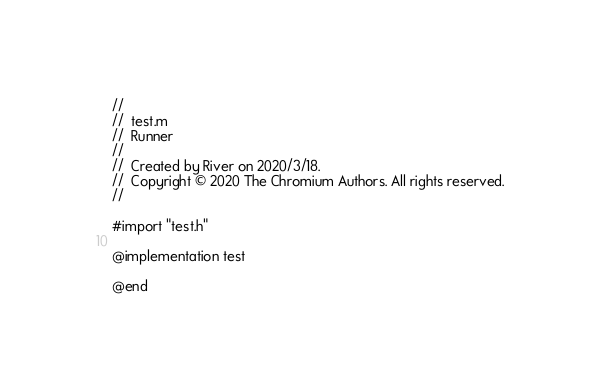Convert code to text. <code><loc_0><loc_0><loc_500><loc_500><_ObjectiveC_>//
//  test.m
//  Runner
//
//  Created by River on 2020/3/18.
//  Copyright © 2020 The Chromium Authors. All rights reserved.
//

#import "test.h"

@implementation test

@end
</code> 